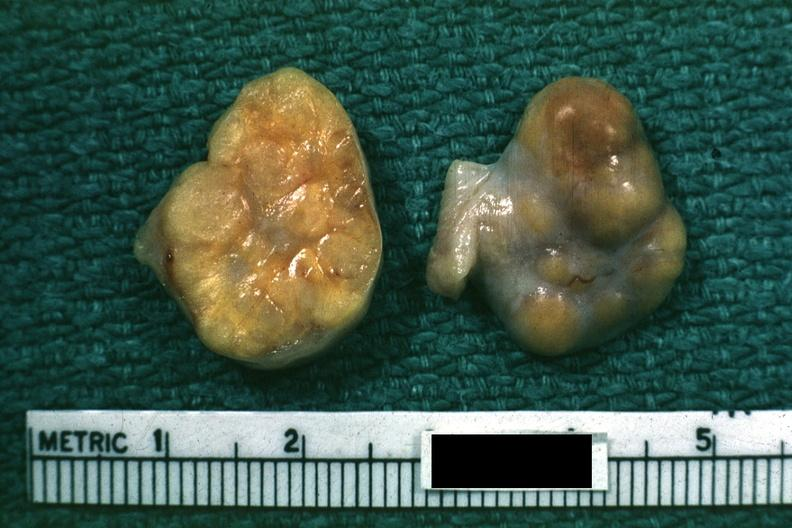s an opened peritoneal cavity cause by fibrous band strangulation present?
Answer the question using a single word or phrase. No 